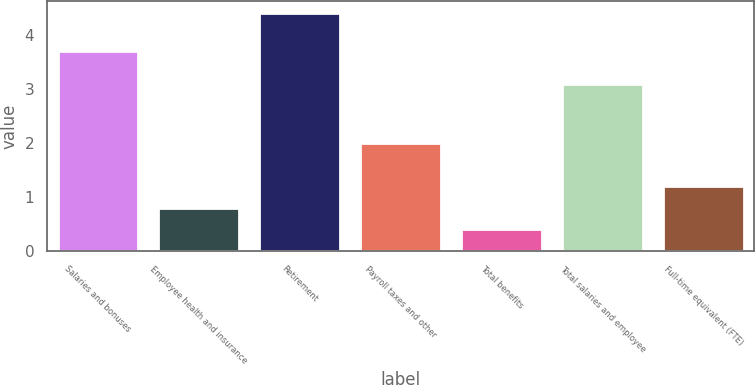Convert chart to OTSL. <chart><loc_0><loc_0><loc_500><loc_500><bar_chart><fcel>Salaries and bonuses<fcel>Employee health and insurance<fcel>Retirement<fcel>Payroll taxes and other<fcel>Total benefits<fcel>Total salaries and employee<fcel>Full-time equivalent (FTE)<nl><fcel>3.7<fcel>0.8<fcel>4.4<fcel>2<fcel>0.4<fcel>3.1<fcel>1.2<nl></chart> 